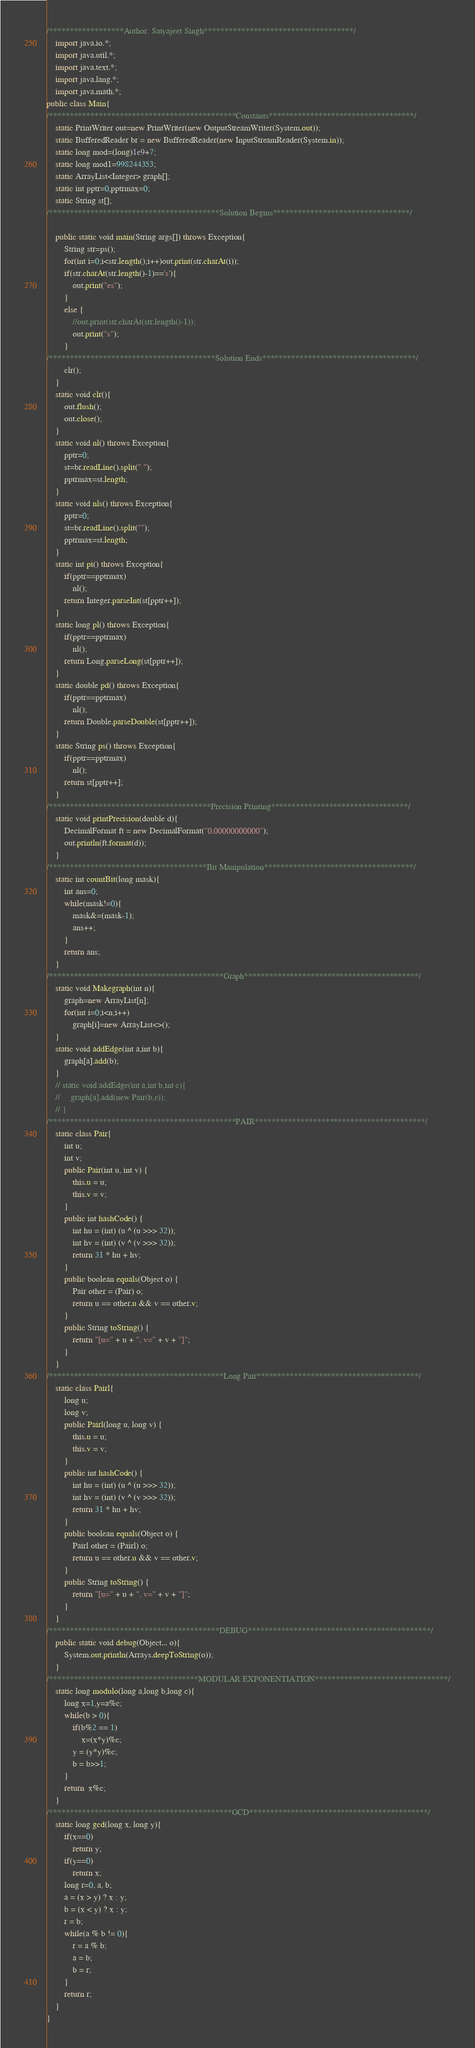Convert code to text. <code><loc_0><loc_0><loc_500><loc_500><_Java_>/******************Author: Satyajeet Singh************************************/
    import java.io.*;
    import java.util.*;
    import java.text.*; 
    import java.lang.*;
    import java.math.*;
public class Main{
/*********************************************Constants***********************************/
    static PrintWriter out=new PrintWriter(new OutputStreamWriter(System.out));        
    static BufferedReader br = new BufferedReader(new InputStreamReader(System.in));
    static long mod=(long)1e9+7;
    static long mod1=998244353;
    static ArrayList<Integer> graph[];
    static int pptr=0,pptrmax=0;
    static String st[];
/*****************************************Solution Begins*********************************/
    
    public static void main(String args[]) throws Exception{
        String str=ps();
        for(int i=0;i<str.length();i++)out.print(str.charAt(i));
        if(str.charAt(str.length()-1)=='s'){
            out.print("es");
        }   
        else {
            //out.print(str.charAt(str.length()-1));
            out.print("s");
        }
/****************************************Solution Ends*************************************/
        clr();
    }
    static void clr(){
        out.flush();
        out.close();
    }
    static void nl() throws Exception{
        pptr=0;
        st=br.readLine().split(" ");
        pptrmax=st.length;
    }
    static void nls() throws Exception{
        pptr=0;
        st=br.readLine().split("");
        pptrmax=st.length;
    }
    static int pi() throws Exception{
        if(pptr==pptrmax)
            nl();
        return Integer.parseInt(st[pptr++]);
    }
    static long pl() throws Exception{
        if(pptr==pptrmax)
            nl();
        return Long.parseLong(st[pptr++]);
    }
    static double pd() throws Exception{
        if(pptr==pptrmax)
            nl();
        return Double.parseDouble(st[pptr++]);
    }
    static String ps() throws Exception{
        if(pptr==pptrmax)
            nl();
        return st[pptr++];
    }
/***************************************Precision Printing*********************************/
    static void printPrecision(double d){
        DecimalFormat ft = new DecimalFormat("0.00000000000"); 
        out.println(ft.format(d));
    }
/**************************************Bit Manipulation************************************/
    static int countBit(long mask){
        int ans=0;
        while(mask!=0){
            mask&=(mask-1);
            ans++;
        }
        return ans;
    }
/******************************************Graph******************************************/
    static void Makegraph(int n){
        graph=new ArrayList[n];
        for(int i=0;i<n;i++)
            graph[i]=new ArrayList<>();
    }
    static void addEdge(int a,int b){
        graph[a].add(b);
    }
    // static void addEdge(int a,int b,int c){
    //     graph[a].add(new Pair(b,c));
    // }    
/*********************************************PAIR*****************************************/
    static class Pair{
        int u;
        int v;
        public Pair(int u, int v) {
            this.u = u;
            this.v = v;
        }
        public int hashCode() {
            int hu = (int) (u ^ (u >>> 32));
            int hv = (int) (v ^ (v >>> 32));
            return 31 * hu + hv;
        }
        public boolean equals(Object o) {
            Pair other = (Pair) o;
            return u == other.u && v == other.v;
        }
        public String toString() {
            return "[u=" + u + ", v=" + v + "]";
        }
    }
/******************************************Long Pair***************************************/
    static class Pairl{
        long u;
        long v;
        public Pairl(long u, long v) {
            this.u = u;
            this.v = v;
        }
        public int hashCode() {
            int hu = (int) (u ^ (u >>> 32));
            int hv = (int) (v ^ (v >>> 32));
            return 31 * hu + hv;
        }
        public boolean equals(Object o) {
            Pairl other = (Pairl) o;
            return u == other.u && v == other.v;
        }
        public String toString() {
            return "[u=" + u + ", v=" + v + "]";
        }
    }
/*****************************************DEBUG********************************************/
    public static void debug(Object... o){
        System.out.println(Arrays.deepToString(o));
    }
/************************************MODULAR EXPONENTIATION********************************/
    static long modulo(long a,long b,long c){
        long x=1,y=a%c;
        while(b > 0){
            if(b%2 == 1)
                x=(x*y)%c;
            y = (y*y)%c;
            b = b>>1;
        }
        return  x%c;
    }
/********************************************GCD*******************************************/
    static long gcd(long x, long y){
        if(x==0)
            return y;
        if(y==0)
            return x;
        long r=0, a, b;
        a = (x > y) ? x : y; 
        b = (x < y) ? x : y;
        r = b;
        while(a % b != 0){
            r = a % b;
            a = b;
            b = r;
        }
        return r;
    }
}</code> 